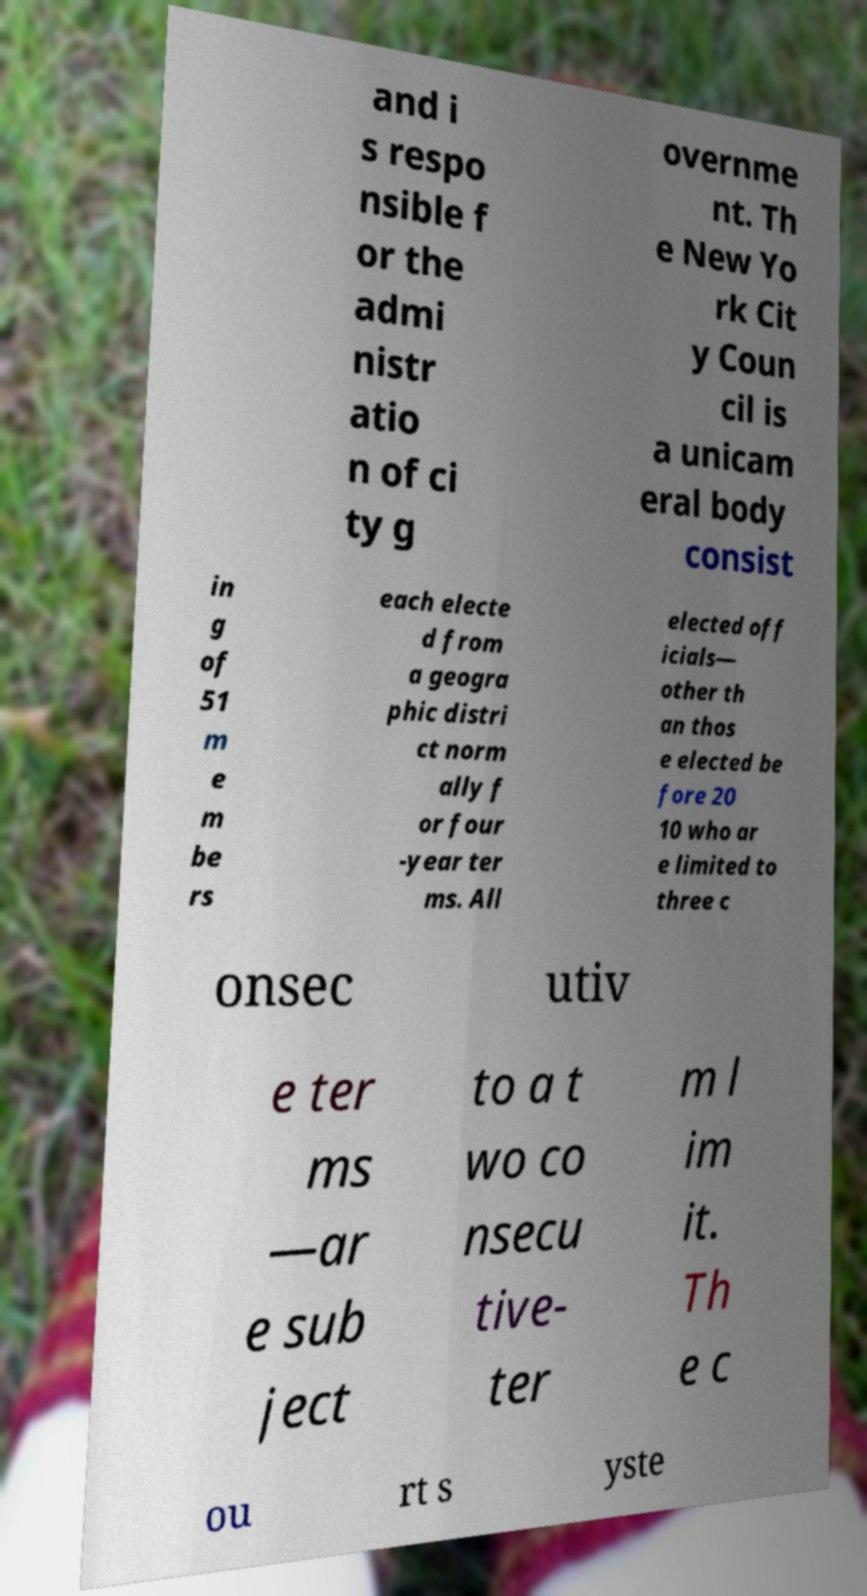I need the written content from this picture converted into text. Can you do that? and i s respo nsible f or the admi nistr atio n of ci ty g overnme nt. Th e New Yo rk Cit y Coun cil is a unicam eral body consist in g of 51 m e m be rs each electe d from a geogra phic distri ct norm ally f or four -year ter ms. All elected off icials— other th an thos e elected be fore 20 10 who ar e limited to three c onsec utiv e ter ms —ar e sub ject to a t wo co nsecu tive- ter m l im it. Th e c ou rt s yste 